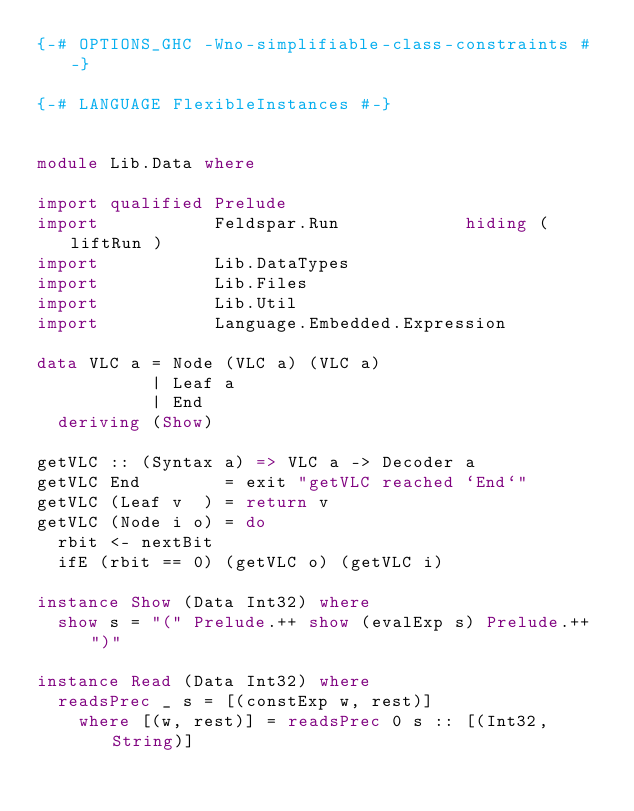<code> <loc_0><loc_0><loc_500><loc_500><_Haskell_>{-# OPTIONS_GHC -Wno-simplifiable-class-constraints #-}

{-# LANGUAGE FlexibleInstances #-}


module Lib.Data where

import qualified Prelude
import           Feldspar.Run            hiding ( liftRun )
import           Lib.DataTypes
import           Lib.Files
import           Lib.Util
import           Language.Embedded.Expression

data VLC a = Node (VLC a) (VLC a)
           | Leaf a
           | End
  deriving (Show)

getVLC :: (Syntax a) => VLC a -> Decoder a
getVLC End        = exit "getVLC reached `End`"
getVLC (Leaf v  ) = return v
getVLC (Node i o) = do
  rbit <- nextBit
  ifE (rbit == 0) (getVLC o) (getVLC i)

instance Show (Data Int32) where
  show s = "(" Prelude.++ show (evalExp s) Prelude.++ ")"

instance Read (Data Int32) where
  readsPrec _ s = [(constExp w, rest)]
    where [(w, rest)] = readsPrec 0 s :: [(Int32, String)]
</code> 